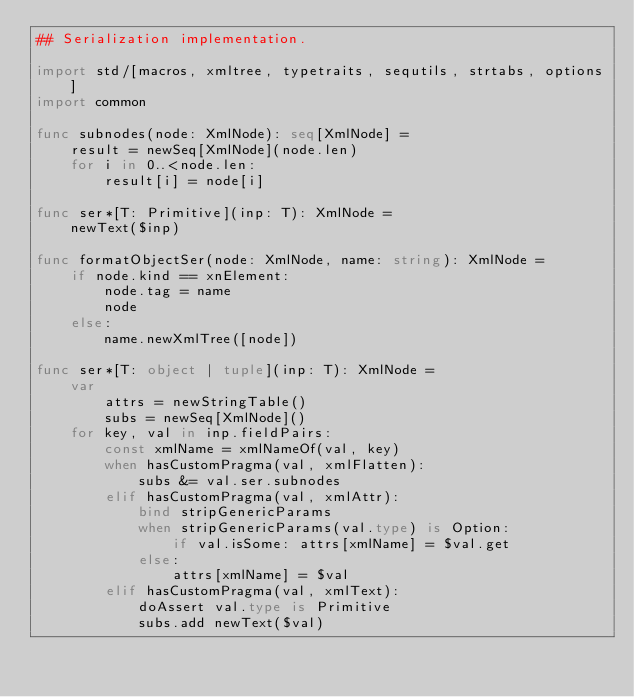<code> <loc_0><loc_0><loc_500><loc_500><_Nim_>## Serialization implementation.

import std/[macros, xmltree, typetraits, sequtils, strtabs, options]
import common

func subnodes(node: XmlNode): seq[XmlNode] =
    result = newSeq[XmlNode](node.len)
    for i in 0..<node.len:
        result[i] = node[i]

func ser*[T: Primitive](inp: T): XmlNode =
    newText($inp)

func formatObjectSer(node: XmlNode, name: string): XmlNode =
    if node.kind == xnElement:
        node.tag = name
        node
    else:
        name.newXmlTree([node])

func ser*[T: object | tuple](inp: T): XmlNode =
    var
        attrs = newStringTable()
        subs = newSeq[XmlNode]()
    for key, val in inp.fieldPairs:
        const xmlName = xmlNameOf(val, key)
        when hasCustomPragma(val, xmlFlatten):
            subs &= val.ser.subnodes
        elif hasCustomPragma(val, xmlAttr):
            bind stripGenericParams
            when stripGenericParams(val.type) is Option:
                if val.isSome: attrs[xmlName] = $val.get
            else:
                attrs[xmlName] = $val
        elif hasCustomPragma(val, xmlText):
            doAssert val.type is Primitive
            subs.add newText($val)</code> 